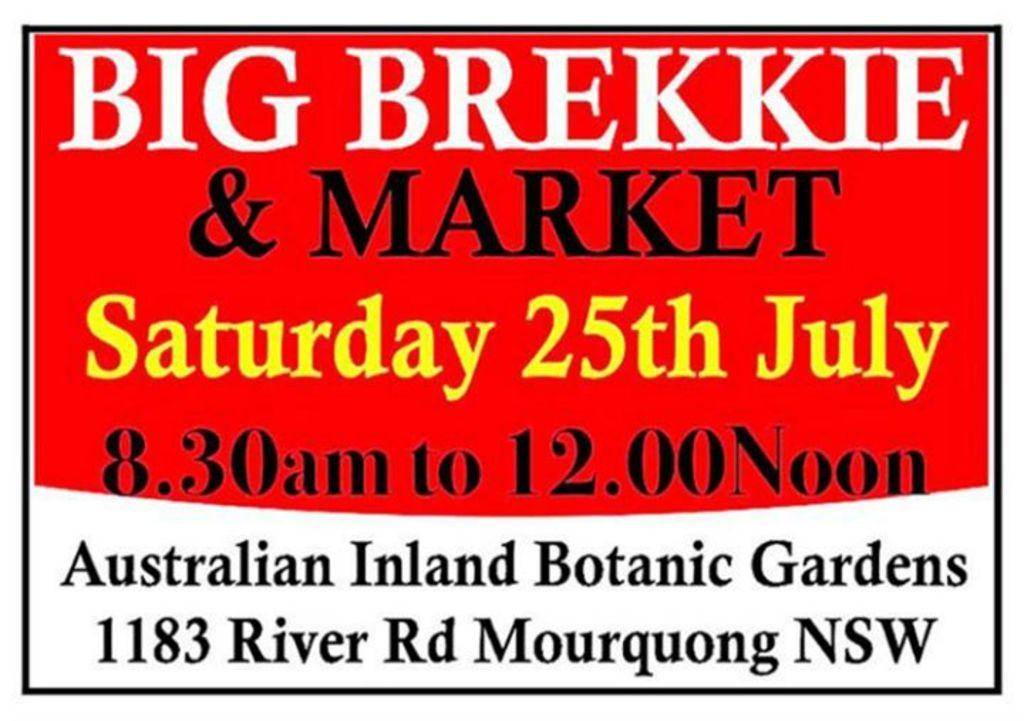<image>
Give a short and clear explanation of the subsequent image. The sign is for the Big Brekkie and Market that will take place on Saturday 25th of July. 